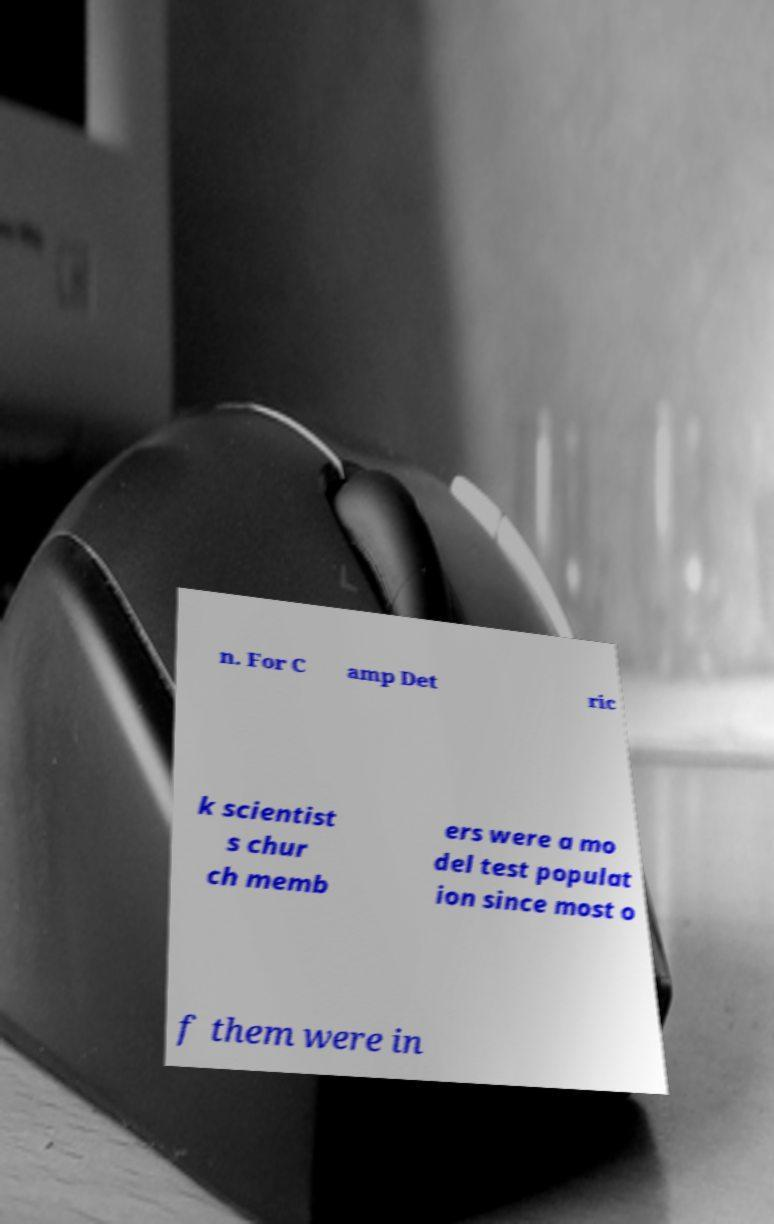Please read and relay the text visible in this image. What does it say? n. For C amp Det ric k scientist s chur ch memb ers were a mo del test populat ion since most o f them were in 